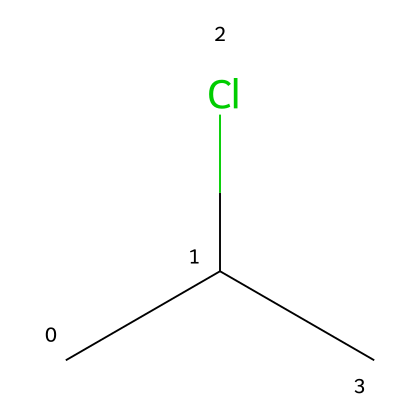What is the molecular formula of this compound? This compound is represented by the SMILES notation CC(Cl)C. Analyzing this, we see that there are three carbon atoms (C), which are counted from the 'C' before and after the 'C(Cl)', and one chlorine atom (Cl) attached to one of the carbon atoms. Therefore, the molecular formula can be deduced as C3H7Cl.
Answer: C3H7Cl How many carbon atoms are present in the structure? From the SMILES CC(Cl)C, we can identify the number of carbon atoms by counting. There are three 'C' present in the notation, indicating that there are three carbon atoms in total.
Answer: 3 What type of bond is between the carbon atoms? In the structure CC(Cl)C, all the carbon atoms are connected by single bonds, as evidenced by the lack of double or triple bond symbols in the SMILES representation. Each carbon atom connects to another carbon atom with a single bond.
Answer: single bond What is the effect of chlorine on the polarity of this compound? The presence of chlorine, which is more electronegative than carbon, introduces a polar covalent bond between Cl and the adjacent carbon atom in CC(Cl)C. This causes the molecule to have a higher overall polarity compared to hydrocarbons without halogens.
Answer: increases polarity Is this compound classified as a saturated or unsaturated hydrocarbon? The SMILES representation shows no double or triple bonds, indicating that all carbon-carbon connections are single bonds. Thus, this compound is classified as saturated.
Answer: saturated Does this chemical structure indicate a plastic? The presence of chlorine in conjunction with a backbone of carbon indicates that this compound is likely a polyvinyl chloride (PVC) structure. As PVC is a common plastic, the chemical structure does indicate that it is associated with plastics.
Answer: yes 